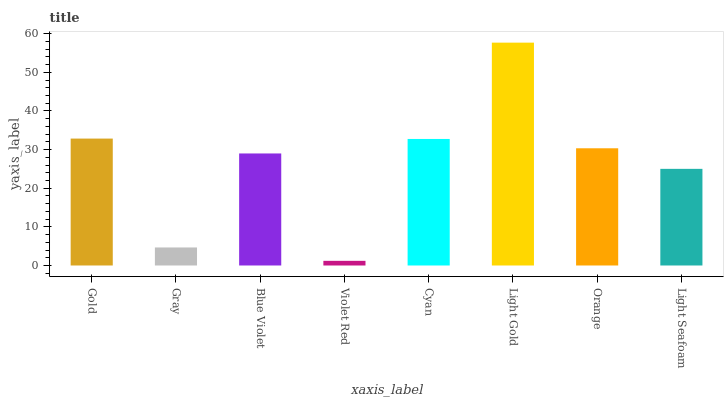Is Violet Red the minimum?
Answer yes or no. Yes. Is Light Gold the maximum?
Answer yes or no. Yes. Is Gray the minimum?
Answer yes or no. No. Is Gray the maximum?
Answer yes or no. No. Is Gold greater than Gray?
Answer yes or no. Yes. Is Gray less than Gold?
Answer yes or no. Yes. Is Gray greater than Gold?
Answer yes or no. No. Is Gold less than Gray?
Answer yes or no. No. Is Orange the high median?
Answer yes or no. Yes. Is Blue Violet the low median?
Answer yes or no. Yes. Is Blue Violet the high median?
Answer yes or no. No. Is Orange the low median?
Answer yes or no. No. 